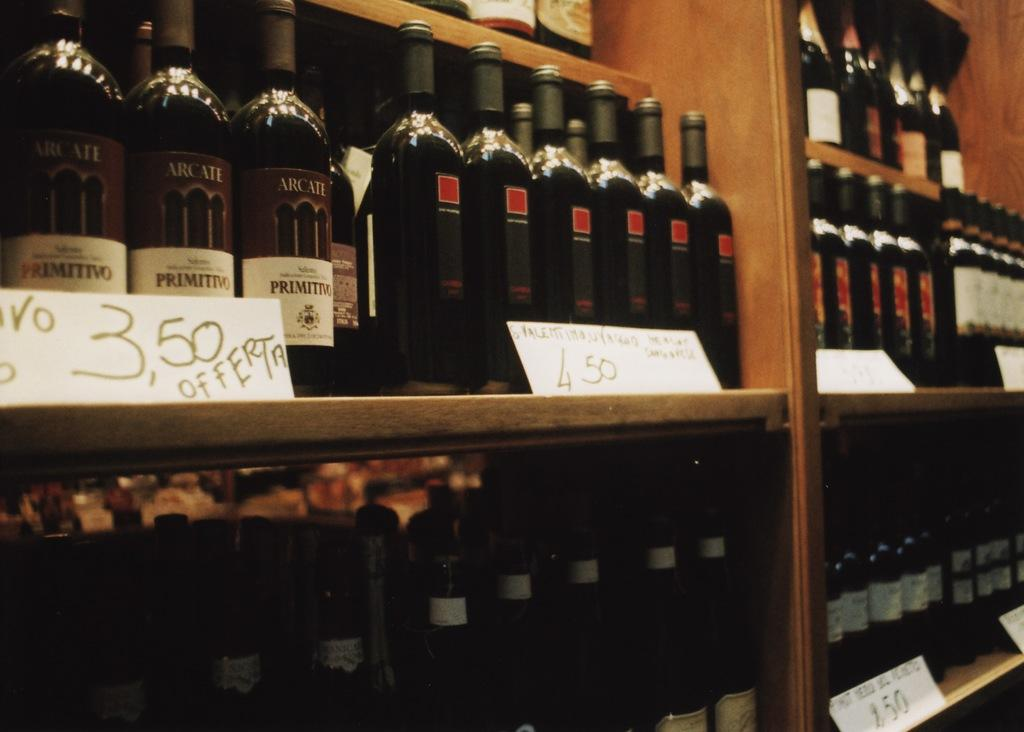<image>
Write a terse but informative summary of the picture. Bottles of wine are placed behind a sign that says 3,50 offerta. 